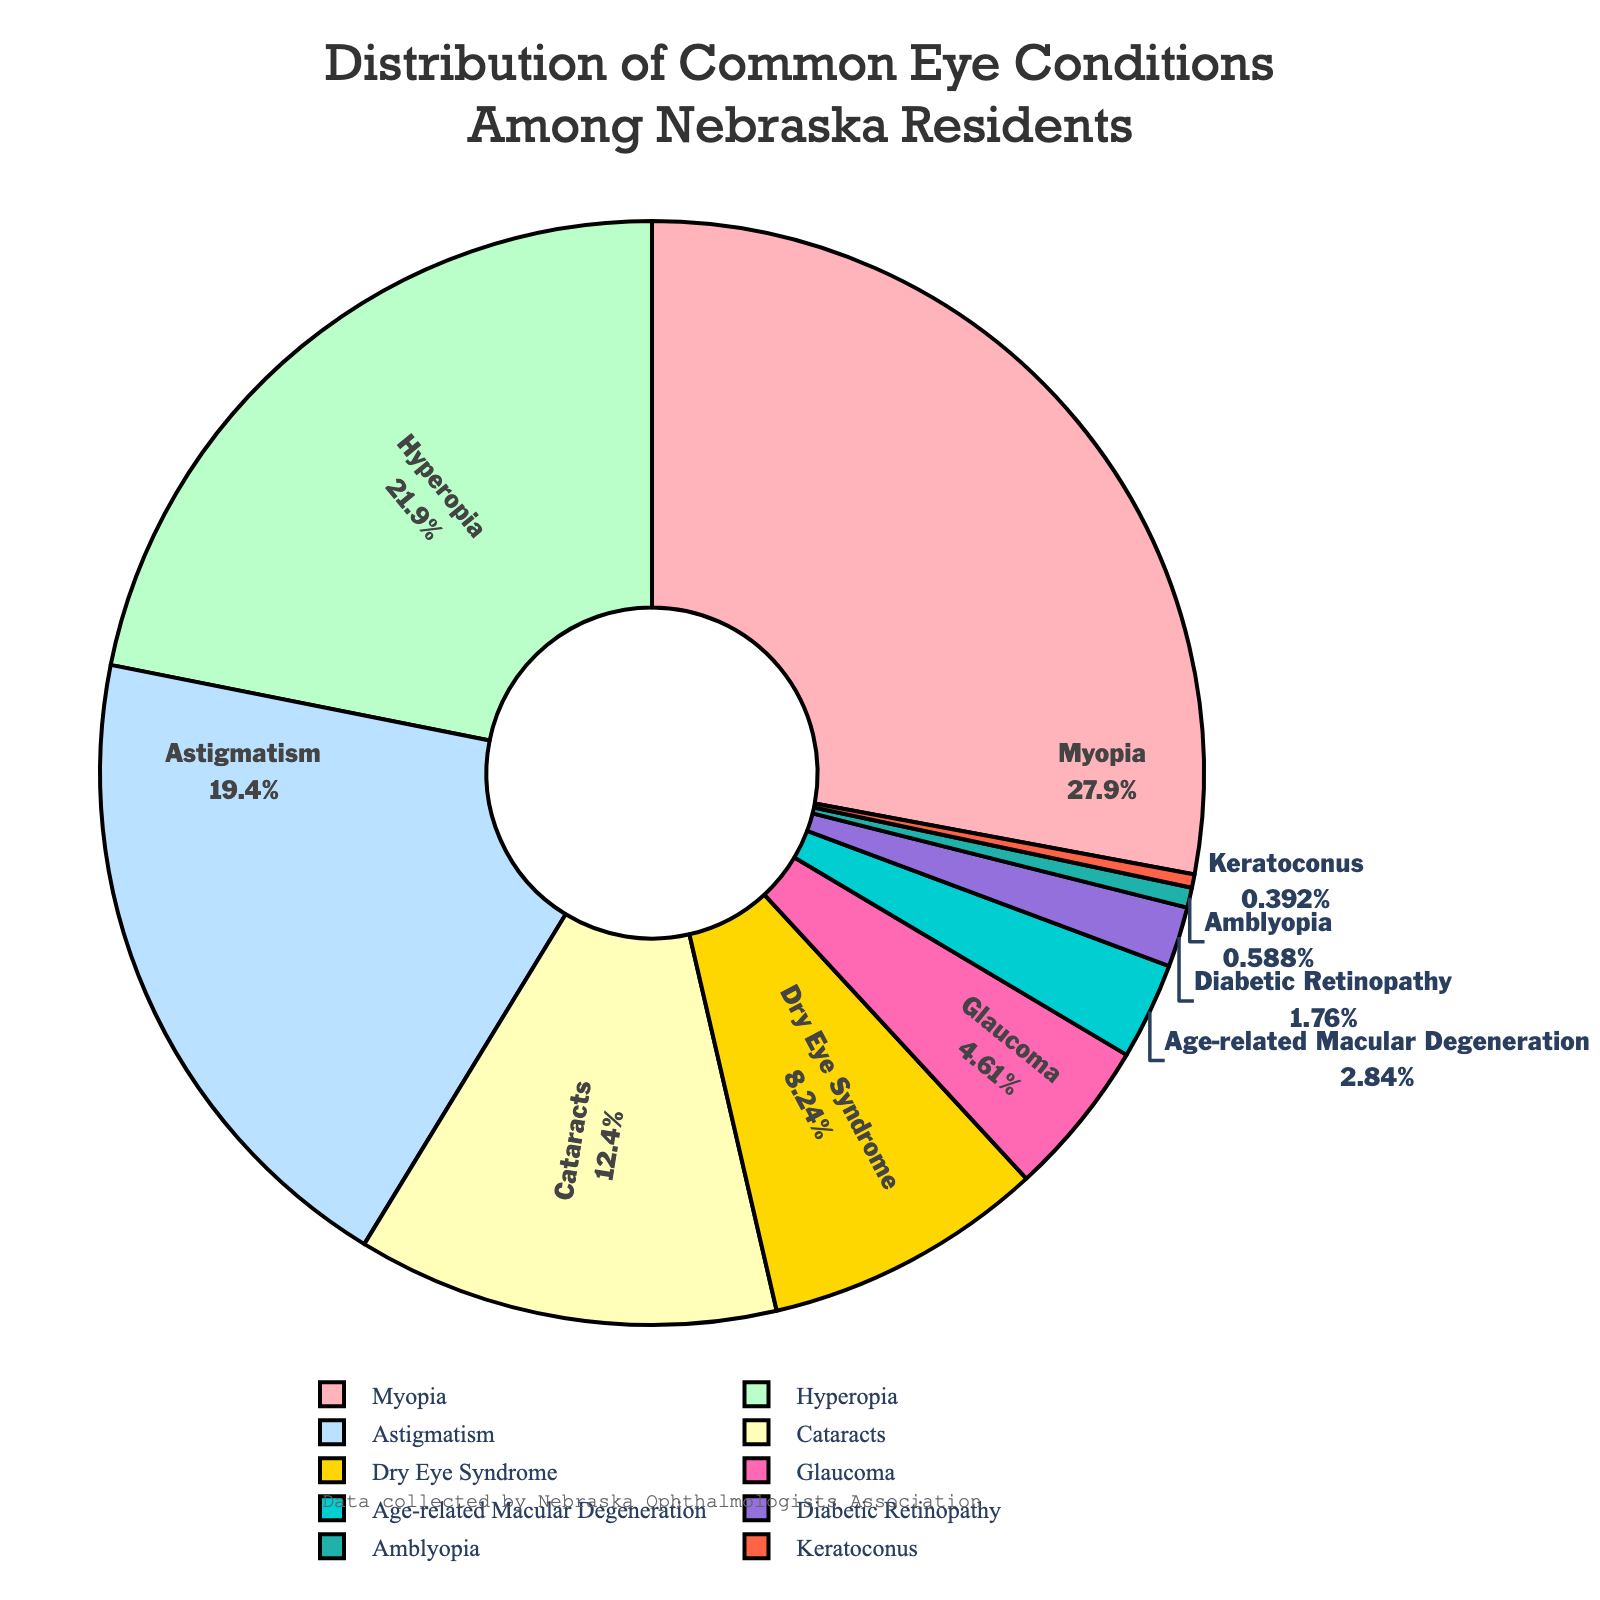What's the most common eye condition among Nebraska residents? The eye condition with the highest percentage in the pie chart is the most common. Observing the figure, Myopia has the highest percentage.
Answer: Myopia What's the combined percentage of Myopia and Hyperopia? To find the combined percentage, sum the percentages of Myopia (28.5) and Hyperopia (22.3). 28.5 + 22.3 = 50.8.
Answer: 50.8% Which condition has a greater prevalence, Astigmatism or Cataracts? By comparing the percentages of Astigmatism (19.8) and Cataracts (12.6), it is evident that Astigmatism's percentage is higher than Cataracts'.
Answer: Astigmatism What percentage of residents suffer from Glaucoma and Diabetic Retinopathy combined? Summing up the percentages of Glaucoma (4.7) and Diabetic Retinopathy (1.8), the combined percentage is 4.7 + 1.8 = 6.5.
Answer: 6.5% What visual feature differentiates Amblyopia's segment from others? Noting the color scheme of the pie chart, Amblyopia's segment is designated in a specific color (red) that distinguishes it from other conditions.
Answer: Its color Compare the percentage of Dry Eye Syndrome and Age-related Macular Degeneration. Which is higher? By comparing the percentages, Dry Eye Syndrome at 8.4% is higher than Age-related Macular Degeneration at 2.9%.
Answer: Dry Eye Syndrome What's the least prevalent eye condition? The eye condition with the smallest percentage in the pie chart is the least prevalent. Observing the figure, Keratoconus has the lowest percentage.
Answer: Keratoconus Which conditions have a higher percentage than Dry Eye Syndrome? By evaluating the percentages, conditions with a higher percentage than Dry Eye Syndrome (8.4) are Myopia (28.5), Hyperopia (22.3), and Astigmatism (19.8).
Answer: Myopia, Hyperopia, Astigmatism 